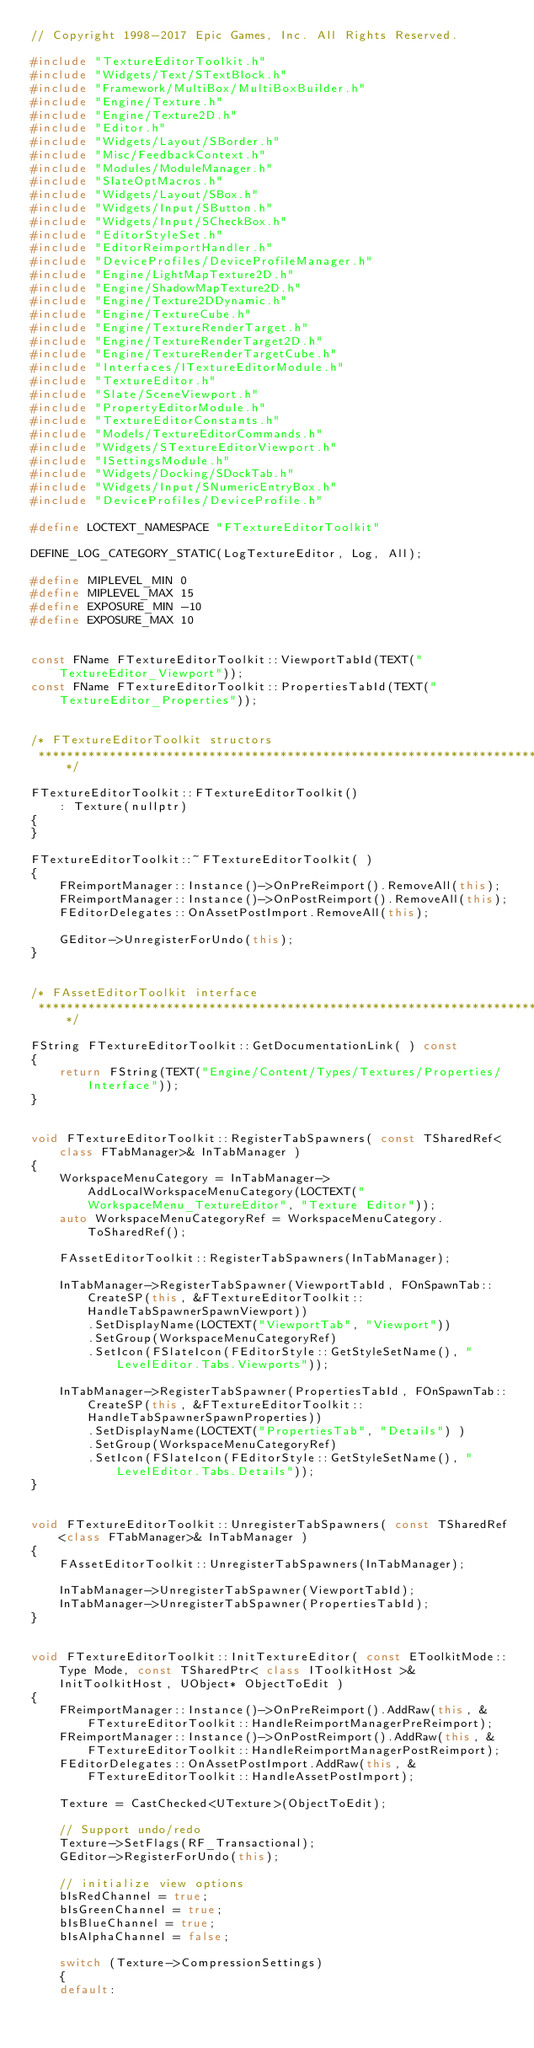Convert code to text. <code><loc_0><loc_0><loc_500><loc_500><_C++_>// Copyright 1998-2017 Epic Games, Inc. All Rights Reserved.

#include "TextureEditorToolkit.h"
#include "Widgets/Text/STextBlock.h"
#include "Framework/MultiBox/MultiBoxBuilder.h"
#include "Engine/Texture.h"
#include "Engine/Texture2D.h"
#include "Editor.h"
#include "Widgets/Layout/SBorder.h"
#include "Misc/FeedbackContext.h"
#include "Modules/ModuleManager.h"
#include "SlateOptMacros.h"
#include "Widgets/Layout/SBox.h"
#include "Widgets/Input/SButton.h"
#include "Widgets/Input/SCheckBox.h"
#include "EditorStyleSet.h"
#include "EditorReimportHandler.h"
#include "DeviceProfiles/DeviceProfileManager.h"
#include "Engine/LightMapTexture2D.h"
#include "Engine/ShadowMapTexture2D.h"
#include "Engine/Texture2DDynamic.h"
#include "Engine/TextureCube.h"
#include "Engine/TextureRenderTarget.h"
#include "Engine/TextureRenderTarget2D.h"
#include "Engine/TextureRenderTargetCube.h"
#include "Interfaces/ITextureEditorModule.h"
#include "TextureEditor.h"
#include "Slate/SceneViewport.h"
#include "PropertyEditorModule.h"
#include "TextureEditorConstants.h"
#include "Models/TextureEditorCommands.h"
#include "Widgets/STextureEditorViewport.h"
#include "ISettingsModule.h"
#include "Widgets/Docking/SDockTab.h"
#include "Widgets/Input/SNumericEntryBox.h"
#include "DeviceProfiles/DeviceProfile.h"

#define LOCTEXT_NAMESPACE "FTextureEditorToolkit"

DEFINE_LOG_CATEGORY_STATIC(LogTextureEditor, Log, All);

#define MIPLEVEL_MIN 0
#define MIPLEVEL_MAX 15
#define EXPOSURE_MIN -10
#define EXPOSURE_MAX 10


const FName FTextureEditorToolkit::ViewportTabId(TEXT("TextureEditor_Viewport"));
const FName FTextureEditorToolkit::PropertiesTabId(TEXT("TextureEditor_Properties"));


/* FTextureEditorToolkit structors
 *****************************************************************************/

FTextureEditorToolkit::FTextureEditorToolkit()
	: Texture(nullptr)
{
}

FTextureEditorToolkit::~FTextureEditorToolkit( )
{
	FReimportManager::Instance()->OnPreReimport().RemoveAll(this);
	FReimportManager::Instance()->OnPostReimport().RemoveAll(this);
	FEditorDelegates::OnAssetPostImport.RemoveAll(this);

	GEditor->UnregisterForUndo(this);
}


/* FAssetEditorToolkit interface
 *****************************************************************************/

FString FTextureEditorToolkit::GetDocumentationLink( ) const 
{
	return FString(TEXT("Engine/Content/Types/Textures/Properties/Interface"));
}


void FTextureEditorToolkit::RegisterTabSpawners( const TSharedRef<class FTabManager>& InTabManager )
{
	WorkspaceMenuCategory = InTabManager->AddLocalWorkspaceMenuCategory(LOCTEXT("WorkspaceMenu_TextureEditor", "Texture Editor"));
	auto WorkspaceMenuCategoryRef = WorkspaceMenuCategory.ToSharedRef();

	FAssetEditorToolkit::RegisterTabSpawners(InTabManager);

	InTabManager->RegisterTabSpawner(ViewportTabId, FOnSpawnTab::CreateSP(this, &FTextureEditorToolkit::HandleTabSpawnerSpawnViewport))
		.SetDisplayName(LOCTEXT("ViewportTab", "Viewport"))
		.SetGroup(WorkspaceMenuCategoryRef)
		.SetIcon(FSlateIcon(FEditorStyle::GetStyleSetName(), "LevelEditor.Tabs.Viewports"));

	InTabManager->RegisterTabSpawner(PropertiesTabId, FOnSpawnTab::CreateSP(this, &FTextureEditorToolkit::HandleTabSpawnerSpawnProperties))
		.SetDisplayName(LOCTEXT("PropertiesTab", "Details") )
		.SetGroup(WorkspaceMenuCategoryRef)
		.SetIcon(FSlateIcon(FEditorStyle::GetStyleSetName(), "LevelEditor.Tabs.Details"));
}


void FTextureEditorToolkit::UnregisterTabSpawners( const TSharedRef<class FTabManager>& InTabManager )
{
	FAssetEditorToolkit::UnregisterTabSpawners(InTabManager);

	InTabManager->UnregisterTabSpawner(ViewportTabId);
	InTabManager->UnregisterTabSpawner(PropertiesTabId);
}


void FTextureEditorToolkit::InitTextureEditor( const EToolkitMode::Type Mode, const TSharedPtr< class IToolkitHost >& InitToolkitHost, UObject* ObjectToEdit )
{
	FReimportManager::Instance()->OnPreReimport().AddRaw(this, &FTextureEditorToolkit::HandleReimportManagerPreReimport);
	FReimportManager::Instance()->OnPostReimport().AddRaw(this, &FTextureEditorToolkit::HandleReimportManagerPostReimport);
	FEditorDelegates::OnAssetPostImport.AddRaw(this, &FTextureEditorToolkit::HandleAssetPostImport);

	Texture = CastChecked<UTexture>(ObjectToEdit);

	// Support undo/redo
	Texture->SetFlags(RF_Transactional);
	GEditor->RegisterForUndo(this);

	// initialize view options
	bIsRedChannel = true;
	bIsGreenChannel = true;
	bIsBlueChannel = true;
	bIsAlphaChannel = false;

	switch (Texture->CompressionSettings)
	{
	default:</code> 